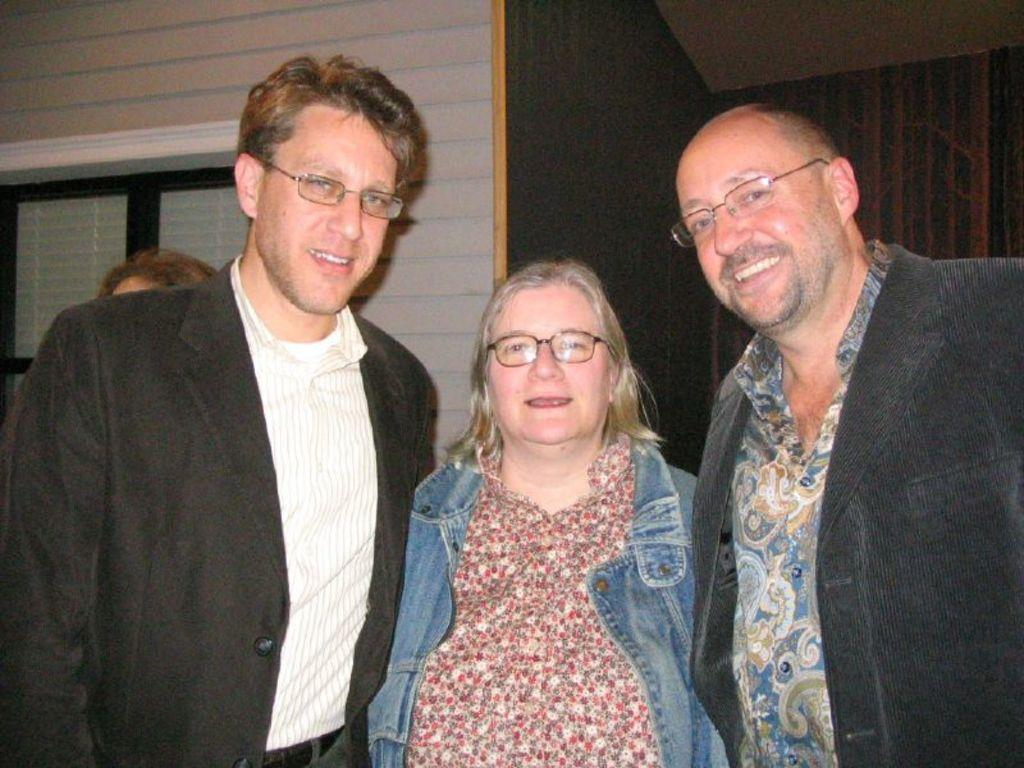How many people are in the image? There are three people in the image: two men and a woman. What are the people in the image doing? The people are standing and smiling. What can be seen in the background of the image? There is a wall and a window in the background of the image. What is the cent of the fear in the image? There is no mention of fear or a cent in the image, so this question cannot be answered. 